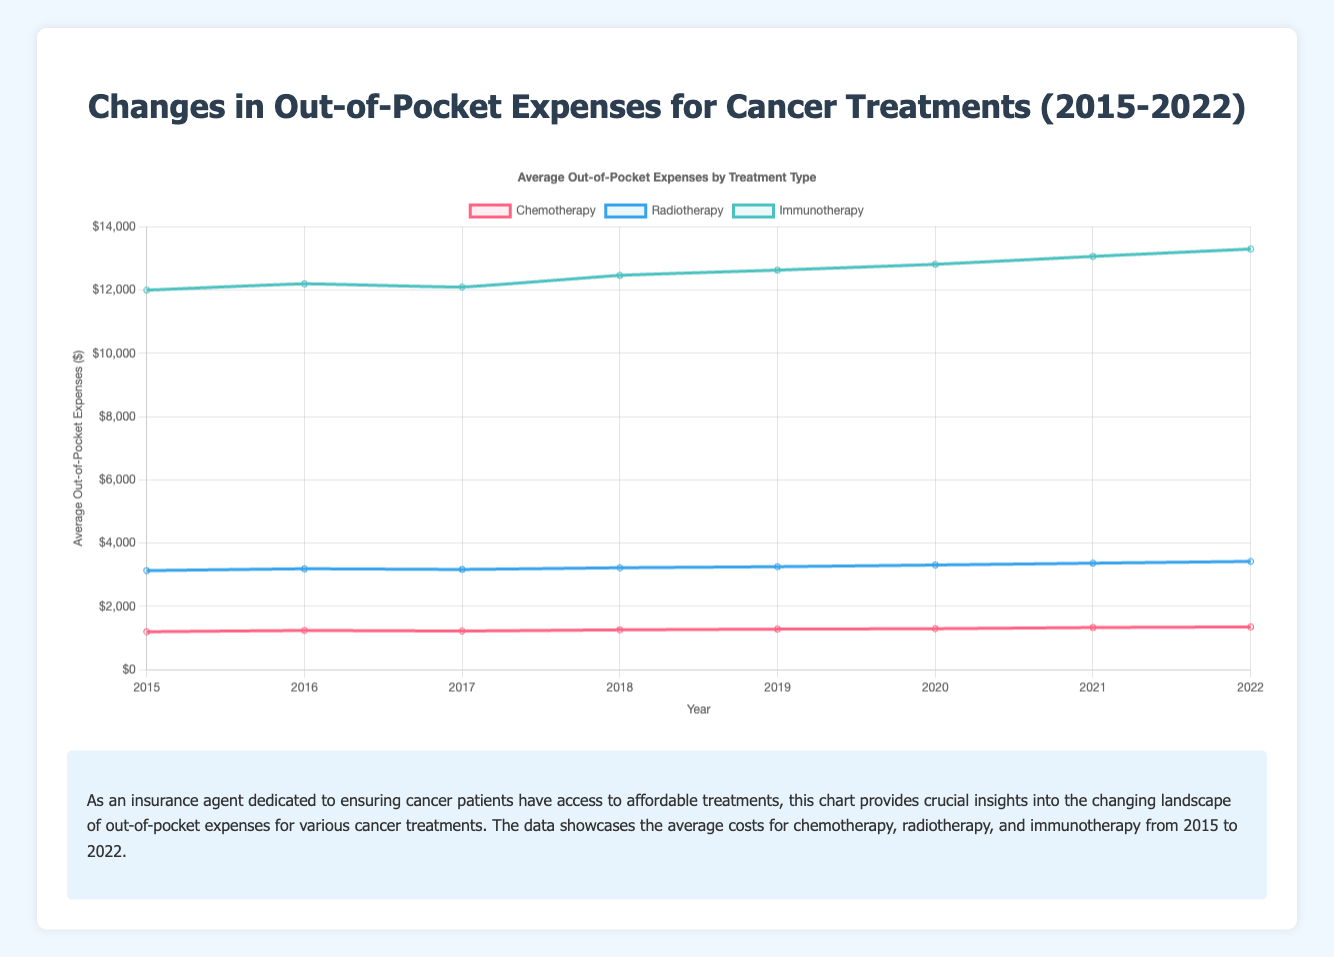What is the average out-of-pocket expense for immunotherapy in 2019? To find the average out-of-pocket expense for immunotherapy in 2019, refer to the immunotherapy data point for that year on the plot. The expense is $12,633.
Answer: $12,633 How much did the out-of-pocket expenses for chemotherapy increase from 2015 to 2022? To determine the increase, subtract the 2015 expense from the 2022 expense for chemotherapy. The difference is $1,353 - $1,200 = $153.
Answer: $153 Which treatment type had the highest out-of-pocket expense in 2020? Check the data points for each treatment type for the year 2020. Immunotherapy has the highest expense at $12,817.
Answer: Immunotherapy Compare the out-of-pocket expenses for radiotherapy and chemotherapy in 2018. Which one is higher and by how much? Look at the 2018 data points for both radiotherapy and chemotherapy. Radiotherapy is $3,223, and chemotherapy is $1,260. The difference is $3,223 - $1,260 = $1,963, with radiotherapy being higher.
Answer: Radiotherapy, $1,963 What is the trend for chemotherapy out-of-pocket expenses from 2015 to 2022? Analyze the chemotherapy line from 2015 to 2022. The trend shows a general increase in expenses over the years.
Answer: Increasing During which year was the out-of-pocket expense for radiotherapy closest to $3,200? Identify the year where the radiotherapy expense is nearest to $3,200. In 2017, the expense is $3,170, which is closest.
Answer: 2017 What is the overall average out-of-pocket expense for chemotherapy from 2015 to 2022? Calculate the average by adding each year's expense and dividing by the number of years. Sum of expenses: $1,200 + $1,240 + $1,223 + $1,260 + $1,283 + $1,297 + $1,333 + $1,353 = $10,189. Average: $10,189 / 8 = $1,273.63.
Answer: $1,273.63 Which year saw the highest percentage increase in out-of-pocket expenses for radiotherapy compared to the previous year? Find the year-over-year percentage change for radiotherapy expenses and identify the highest one. For example, from 2019 to 2020: (($3,310 - $3,257) / $3,257) * 100 = 1.63%. Repeat for other years; 2015 to 2016 has the highest at 1.82%.
Answer: 2016 How do the trends in out-of-pocket expenses for chemotherapy and radiotherapy compare from 2015 to 2022? Compare the general slopes of the lines for both treatment types. Both show increasing trends, but radiotherapy has a steeper increase than chemotherapy over time.
Answer: Both increasing; radiotherapy steeper What was the cost difference between the most and least expensive immunotherapy treatments in 2022? Subtract the least expensive treatment (Nivolumab) from the most expensive treatment (Ipilimumab) in 2022. The difference is $14,400 - $12,300 = $2,100.
Answer: $2,100 